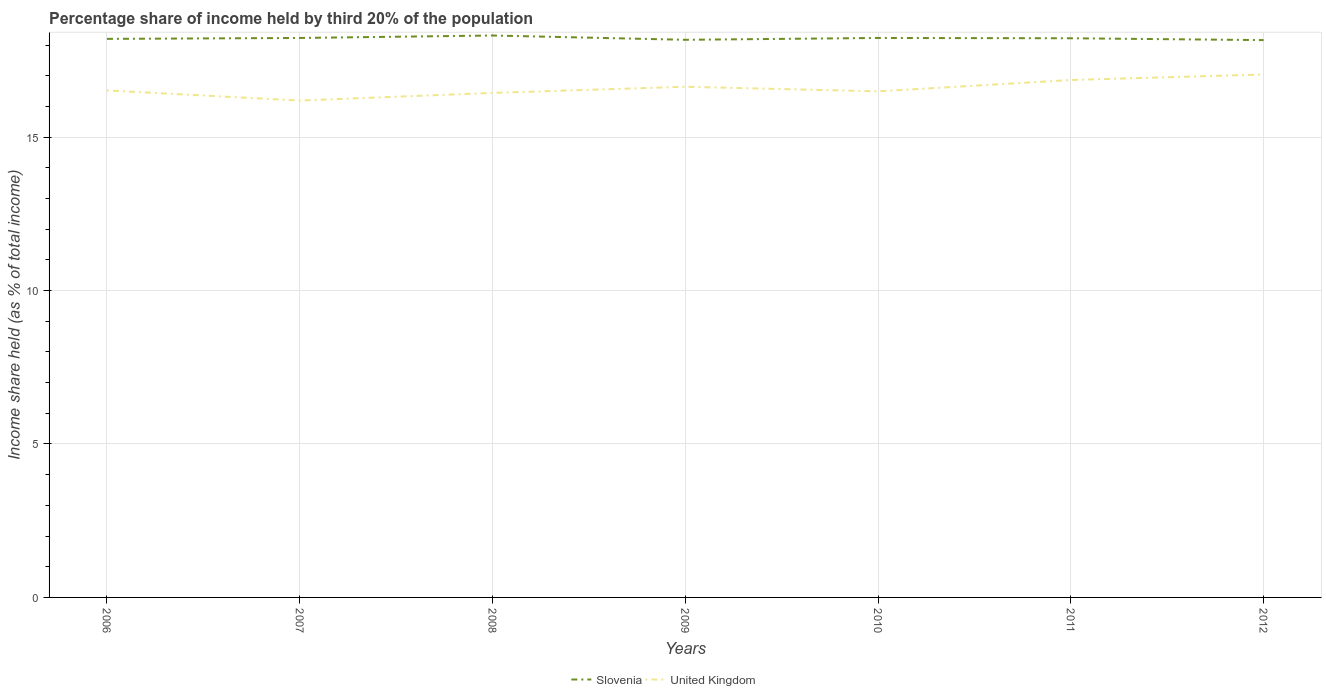How many different coloured lines are there?
Ensure brevity in your answer.  2. Does the line corresponding to Slovenia intersect with the line corresponding to United Kingdom?
Provide a succinct answer. No. Across all years, what is the maximum share of income held by third 20% of the population in United Kingdom?
Your response must be concise. 16.19. What is the total share of income held by third 20% of the population in United Kingdom in the graph?
Your answer should be compact. -0.12. What is the difference between the highest and the second highest share of income held by third 20% of the population in Slovenia?
Keep it short and to the point. 0.15. What is the difference between the highest and the lowest share of income held by third 20% of the population in United Kingdom?
Make the answer very short. 3. Is the share of income held by third 20% of the population in Slovenia strictly greater than the share of income held by third 20% of the population in United Kingdom over the years?
Provide a succinct answer. No. How many lines are there?
Your answer should be very brief. 2. Does the graph contain any zero values?
Keep it short and to the point. No. Does the graph contain grids?
Offer a very short reply. Yes. What is the title of the graph?
Your response must be concise. Percentage share of income held by third 20% of the population. Does "Namibia" appear as one of the legend labels in the graph?
Your answer should be compact. No. What is the label or title of the X-axis?
Offer a very short reply. Years. What is the label or title of the Y-axis?
Your answer should be compact. Income share held (as % of total income). What is the Income share held (as % of total income) in Slovenia in 2006?
Your answer should be compact. 18.2. What is the Income share held (as % of total income) in United Kingdom in 2006?
Make the answer very short. 16.52. What is the Income share held (as % of total income) in Slovenia in 2007?
Offer a very short reply. 18.23. What is the Income share held (as % of total income) of United Kingdom in 2007?
Provide a short and direct response. 16.19. What is the Income share held (as % of total income) in Slovenia in 2008?
Your response must be concise. 18.31. What is the Income share held (as % of total income) in United Kingdom in 2008?
Make the answer very short. 16.44. What is the Income share held (as % of total income) in Slovenia in 2009?
Make the answer very short. 18.17. What is the Income share held (as % of total income) in United Kingdom in 2009?
Provide a short and direct response. 16.64. What is the Income share held (as % of total income) in Slovenia in 2010?
Provide a succinct answer. 18.23. What is the Income share held (as % of total income) of United Kingdom in 2010?
Provide a succinct answer. 16.49. What is the Income share held (as % of total income) in Slovenia in 2011?
Give a very brief answer. 18.22. What is the Income share held (as % of total income) of United Kingdom in 2011?
Provide a short and direct response. 16.86. What is the Income share held (as % of total income) of Slovenia in 2012?
Offer a terse response. 18.16. What is the Income share held (as % of total income) of United Kingdom in 2012?
Provide a short and direct response. 17.04. Across all years, what is the maximum Income share held (as % of total income) in Slovenia?
Ensure brevity in your answer.  18.31. Across all years, what is the maximum Income share held (as % of total income) in United Kingdom?
Your response must be concise. 17.04. Across all years, what is the minimum Income share held (as % of total income) in Slovenia?
Your answer should be very brief. 18.16. Across all years, what is the minimum Income share held (as % of total income) of United Kingdom?
Ensure brevity in your answer.  16.19. What is the total Income share held (as % of total income) in Slovenia in the graph?
Offer a very short reply. 127.52. What is the total Income share held (as % of total income) of United Kingdom in the graph?
Your response must be concise. 116.18. What is the difference between the Income share held (as % of total income) in Slovenia in 2006 and that in 2007?
Give a very brief answer. -0.03. What is the difference between the Income share held (as % of total income) in United Kingdom in 2006 and that in 2007?
Your answer should be compact. 0.33. What is the difference between the Income share held (as % of total income) of Slovenia in 2006 and that in 2008?
Your response must be concise. -0.11. What is the difference between the Income share held (as % of total income) in United Kingdom in 2006 and that in 2009?
Ensure brevity in your answer.  -0.12. What is the difference between the Income share held (as % of total income) in Slovenia in 2006 and that in 2010?
Your answer should be compact. -0.03. What is the difference between the Income share held (as % of total income) in United Kingdom in 2006 and that in 2010?
Offer a terse response. 0.03. What is the difference between the Income share held (as % of total income) of Slovenia in 2006 and that in 2011?
Make the answer very short. -0.02. What is the difference between the Income share held (as % of total income) in United Kingdom in 2006 and that in 2011?
Your answer should be compact. -0.34. What is the difference between the Income share held (as % of total income) in United Kingdom in 2006 and that in 2012?
Your answer should be compact. -0.52. What is the difference between the Income share held (as % of total income) in Slovenia in 2007 and that in 2008?
Provide a short and direct response. -0.08. What is the difference between the Income share held (as % of total income) in United Kingdom in 2007 and that in 2009?
Offer a very short reply. -0.45. What is the difference between the Income share held (as % of total income) of United Kingdom in 2007 and that in 2010?
Keep it short and to the point. -0.3. What is the difference between the Income share held (as % of total income) of Slovenia in 2007 and that in 2011?
Ensure brevity in your answer.  0.01. What is the difference between the Income share held (as % of total income) in United Kingdom in 2007 and that in 2011?
Your response must be concise. -0.67. What is the difference between the Income share held (as % of total income) in Slovenia in 2007 and that in 2012?
Ensure brevity in your answer.  0.07. What is the difference between the Income share held (as % of total income) of United Kingdom in 2007 and that in 2012?
Offer a terse response. -0.85. What is the difference between the Income share held (as % of total income) of Slovenia in 2008 and that in 2009?
Offer a terse response. 0.14. What is the difference between the Income share held (as % of total income) in Slovenia in 2008 and that in 2010?
Your answer should be very brief. 0.08. What is the difference between the Income share held (as % of total income) of United Kingdom in 2008 and that in 2010?
Offer a terse response. -0.05. What is the difference between the Income share held (as % of total income) of Slovenia in 2008 and that in 2011?
Keep it short and to the point. 0.09. What is the difference between the Income share held (as % of total income) in United Kingdom in 2008 and that in 2011?
Your response must be concise. -0.42. What is the difference between the Income share held (as % of total income) in Slovenia in 2008 and that in 2012?
Give a very brief answer. 0.15. What is the difference between the Income share held (as % of total income) of Slovenia in 2009 and that in 2010?
Make the answer very short. -0.06. What is the difference between the Income share held (as % of total income) in United Kingdom in 2009 and that in 2011?
Provide a short and direct response. -0.22. What is the difference between the Income share held (as % of total income) in Slovenia in 2009 and that in 2012?
Your response must be concise. 0.01. What is the difference between the Income share held (as % of total income) of United Kingdom in 2010 and that in 2011?
Provide a succinct answer. -0.37. What is the difference between the Income share held (as % of total income) of Slovenia in 2010 and that in 2012?
Give a very brief answer. 0.07. What is the difference between the Income share held (as % of total income) in United Kingdom in 2010 and that in 2012?
Your answer should be very brief. -0.55. What is the difference between the Income share held (as % of total income) in United Kingdom in 2011 and that in 2012?
Keep it short and to the point. -0.18. What is the difference between the Income share held (as % of total income) in Slovenia in 2006 and the Income share held (as % of total income) in United Kingdom in 2007?
Your answer should be compact. 2.01. What is the difference between the Income share held (as % of total income) in Slovenia in 2006 and the Income share held (as % of total income) in United Kingdom in 2008?
Your answer should be compact. 1.76. What is the difference between the Income share held (as % of total income) of Slovenia in 2006 and the Income share held (as % of total income) of United Kingdom in 2009?
Give a very brief answer. 1.56. What is the difference between the Income share held (as % of total income) of Slovenia in 2006 and the Income share held (as % of total income) of United Kingdom in 2010?
Offer a terse response. 1.71. What is the difference between the Income share held (as % of total income) of Slovenia in 2006 and the Income share held (as % of total income) of United Kingdom in 2011?
Offer a very short reply. 1.34. What is the difference between the Income share held (as % of total income) of Slovenia in 2006 and the Income share held (as % of total income) of United Kingdom in 2012?
Make the answer very short. 1.16. What is the difference between the Income share held (as % of total income) in Slovenia in 2007 and the Income share held (as % of total income) in United Kingdom in 2008?
Keep it short and to the point. 1.79. What is the difference between the Income share held (as % of total income) in Slovenia in 2007 and the Income share held (as % of total income) in United Kingdom in 2009?
Your answer should be very brief. 1.59. What is the difference between the Income share held (as % of total income) of Slovenia in 2007 and the Income share held (as % of total income) of United Kingdom in 2010?
Your response must be concise. 1.74. What is the difference between the Income share held (as % of total income) of Slovenia in 2007 and the Income share held (as % of total income) of United Kingdom in 2011?
Your answer should be compact. 1.37. What is the difference between the Income share held (as % of total income) in Slovenia in 2007 and the Income share held (as % of total income) in United Kingdom in 2012?
Offer a terse response. 1.19. What is the difference between the Income share held (as % of total income) in Slovenia in 2008 and the Income share held (as % of total income) in United Kingdom in 2009?
Ensure brevity in your answer.  1.67. What is the difference between the Income share held (as % of total income) of Slovenia in 2008 and the Income share held (as % of total income) of United Kingdom in 2010?
Your answer should be compact. 1.82. What is the difference between the Income share held (as % of total income) of Slovenia in 2008 and the Income share held (as % of total income) of United Kingdom in 2011?
Ensure brevity in your answer.  1.45. What is the difference between the Income share held (as % of total income) in Slovenia in 2008 and the Income share held (as % of total income) in United Kingdom in 2012?
Your answer should be very brief. 1.27. What is the difference between the Income share held (as % of total income) in Slovenia in 2009 and the Income share held (as % of total income) in United Kingdom in 2010?
Give a very brief answer. 1.68. What is the difference between the Income share held (as % of total income) of Slovenia in 2009 and the Income share held (as % of total income) of United Kingdom in 2011?
Make the answer very short. 1.31. What is the difference between the Income share held (as % of total income) of Slovenia in 2009 and the Income share held (as % of total income) of United Kingdom in 2012?
Ensure brevity in your answer.  1.13. What is the difference between the Income share held (as % of total income) in Slovenia in 2010 and the Income share held (as % of total income) in United Kingdom in 2011?
Your answer should be very brief. 1.37. What is the difference between the Income share held (as % of total income) in Slovenia in 2010 and the Income share held (as % of total income) in United Kingdom in 2012?
Your response must be concise. 1.19. What is the difference between the Income share held (as % of total income) in Slovenia in 2011 and the Income share held (as % of total income) in United Kingdom in 2012?
Your answer should be compact. 1.18. What is the average Income share held (as % of total income) in Slovenia per year?
Your answer should be compact. 18.22. What is the average Income share held (as % of total income) of United Kingdom per year?
Your response must be concise. 16.6. In the year 2006, what is the difference between the Income share held (as % of total income) in Slovenia and Income share held (as % of total income) in United Kingdom?
Offer a very short reply. 1.68. In the year 2007, what is the difference between the Income share held (as % of total income) of Slovenia and Income share held (as % of total income) of United Kingdom?
Your answer should be very brief. 2.04. In the year 2008, what is the difference between the Income share held (as % of total income) in Slovenia and Income share held (as % of total income) in United Kingdom?
Offer a very short reply. 1.87. In the year 2009, what is the difference between the Income share held (as % of total income) in Slovenia and Income share held (as % of total income) in United Kingdom?
Offer a terse response. 1.53. In the year 2010, what is the difference between the Income share held (as % of total income) in Slovenia and Income share held (as % of total income) in United Kingdom?
Offer a very short reply. 1.74. In the year 2011, what is the difference between the Income share held (as % of total income) of Slovenia and Income share held (as % of total income) of United Kingdom?
Provide a succinct answer. 1.36. In the year 2012, what is the difference between the Income share held (as % of total income) in Slovenia and Income share held (as % of total income) in United Kingdom?
Offer a very short reply. 1.12. What is the ratio of the Income share held (as % of total income) in Slovenia in 2006 to that in 2007?
Your answer should be very brief. 1. What is the ratio of the Income share held (as % of total income) of United Kingdom in 2006 to that in 2007?
Your response must be concise. 1.02. What is the ratio of the Income share held (as % of total income) in Slovenia in 2006 to that in 2008?
Make the answer very short. 0.99. What is the ratio of the Income share held (as % of total income) in United Kingdom in 2006 to that in 2008?
Give a very brief answer. 1. What is the ratio of the Income share held (as % of total income) of Slovenia in 2006 to that in 2009?
Keep it short and to the point. 1. What is the ratio of the Income share held (as % of total income) in Slovenia in 2006 to that in 2010?
Offer a very short reply. 1. What is the ratio of the Income share held (as % of total income) in United Kingdom in 2006 to that in 2010?
Make the answer very short. 1. What is the ratio of the Income share held (as % of total income) in Slovenia in 2006 to that in 2011?
Offer a very short reply. 1. What is the ratio of the Income share held (as % of total income) in United Kingdom in 2006 to that in 2011?
Your answer should be very brief. 0.98. What is the ratio of the Income share held (as % of total income) in Slovenia in 2006 to that in 2012?
Provide a succinct answer. 1. What is the ratio of the Income share held (as % of total income) in United Kingdom in 2006 to that in 2012?
Keep it short and to the point. 0.97. What is the ratio of the Income share held (as % of total income) in United Kingdom in 2007 to that in 2008?
Keep it short and to the point. 0.98. What is the ratio of the Income share held (as % of total income) of Slovenia in 2007 to that in 2009?
Provide a short and direct response. 1. What is the ratio of the Income share held (as % of total income) of United Kingdom in 2007 to that in 2009?
Your response must be concise. 0.97. What is the ratio of the Income share held (as % of total income) in Slovenia in 2007 to that in 2010?
Make the answer very short. 1. What is the ratio of the Income share held (as % of total income) of United Kingdom in 2007 to that in 2010?
Your response must be concise. 0.98. What is the ratio of the Income share held (as % of total income) in Slovenia in 2007 to that in 2011?
Ensure brevity in your answer.  1. What is the ratio of the Income share held (as % of total income) in United Kingdom in 2007 to that in 2011?
Your answer should be very brief. 0.96. What is the ratio of the Income share held (as % of total income) of United Kingdom in 2007 to that in 2012?
Keep it short and to the point. 0.95. What is the ratio of the Income share held (as % of total income) of Slovenia in 2008 to that in 2009?
Provide a succinct answer. 1.01. What is the ratio of the Income share held (as % of total income) of United Kingdom in 2008 to that in 2009?
Provide a short and direct response. 0.99. What is the ratio of the Income share held (as % of total income) in Slovenia in 2008 to that in 2011?
Provide a short and direct response. 1. What is the ratio of the Income share held (as % of total income) in United Kingdom in 2008 to that in 2011?
Ensure brevity in your answer.  0.98. What is the ratio of the Income share held (as % of total income) in Slovenia in 2008 to that in 2012?
Make the answer very short. 1.01. What is the ratio of the Income share held (as % of total income) in United Kingdom in 2008 to that in 2012?
Your answer should be very brief. 0.96. What is the ratio of the Income share held (as % of total income) in United Kingdom in 2009 to that in 2010?
Give a very brief answer. 1.01. What is the ratio of the Income share held (as % of total income) of Slovenia in 2009 to that in 2011?
Provide a succinct answer. 1. What is the ratio of the Income share held (as % of total income) in Slovenia in 2009 to that in 2012?
Your answer should be very brief. 1. What is the ratio of the Income share held (as % of total income) in United Kingdom in 2009 to that in 2012?
Your answer should be compact. 0.98. What is the ratio of the Income share held (as % of total income) in United Kingdom in 2010 to that in 2011?
Your answer should be compact. 0.98. What is the ratio of the Income share held (as % of total income) in Slovenia in 2010 to that in 2012?
Your answer should be very brief. 1. What is the ratio of the Income share held (as % of total income) of United Kingdom in 2011 to that in 2012?
Offer a terse response. 0.99. What is the difference between the highest and the second highest Income share held (as % of total income) of Slovenia?
Give a very brief answer. 0.08. What is the difference between the highest and the second highest Income share held (as % of total income) of United Kingdom?
Your answer should be very brief. 0.18. What is the difference between the highest and the lowest Income share held (as % of total income) in Slovenia?
Provide a succinct answer. 0.15. 